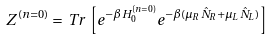Convert formula to latex. <formula><loc_0><loc_0><loc_500><loc_500>Z ^ { ( n = 0 ) } = \, T r \, \left [ e ^ { - \beta H _ { 0 } ^ { ( n = 0 ) } } e ^ { - \beta ( \mu _ { R } \hat { N } _ { R } + \mu _ { L } \hat { N } _ { L } ) } \right ]</formula> 